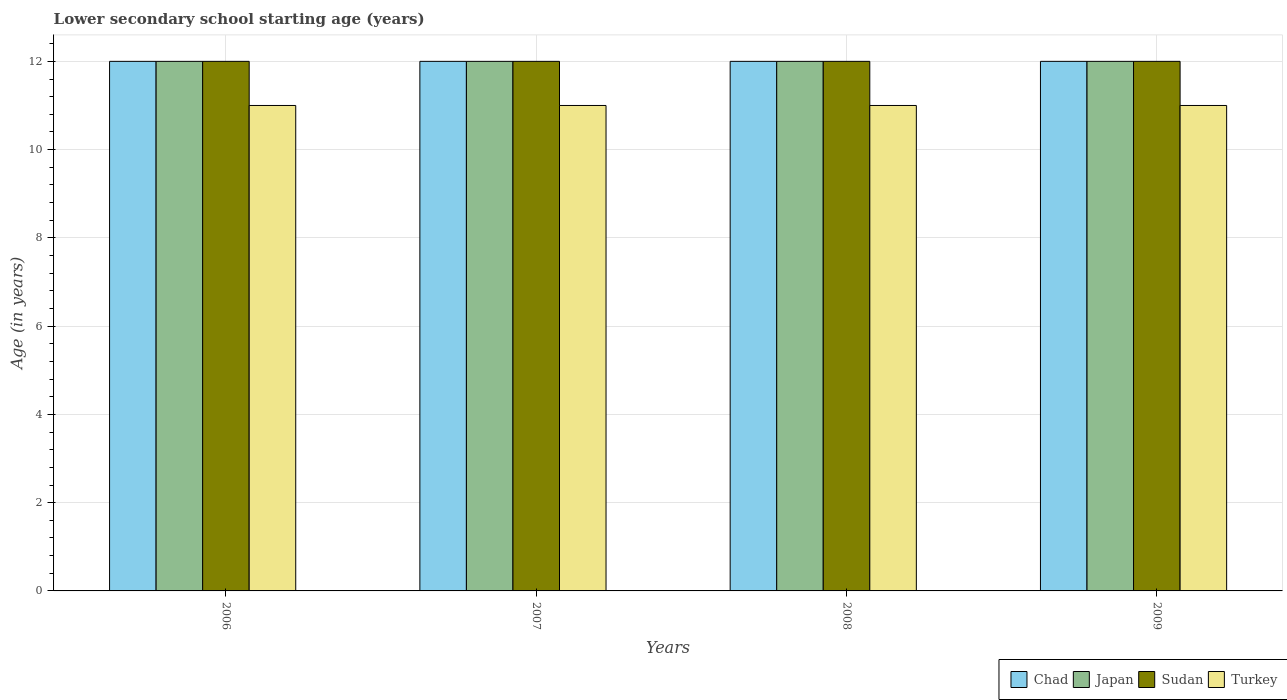What is the label of the 4th group of bars from the left?
Keep it short and to the point. 2009. What is the lower secondary school starting age of children in Turkey in 2008?
Offer a very short reply. 11. Across all years, what is the maximum lower secondary school starting age of children in Sudan?
Your answer should be very brief. 12. Across all years, what is the minimum lower secondary school starting age of children in Turkey?
Your response must be concise. 11. In which year was the lower secondary school starting age of children in Sudan maximum?
Ensure brevity in your answer.  2006. In which year was the lower secondary school starting age of children in Japan minimum?
Make the answer very short. 2006. What is the total lower secondary school starting age of children in Chad in the graph?
Provide a short and direct response. 48. What is the difference between the lower secondary school starting age of children in Chad in 2006 and that in 2007?
Your answer should be very brief. 0. What is the difference between the lower secondary school starting age of children in Japan in 2007 and the lower secondary school starting age of children in Chad in 2009?
Offer a very short reply. 0. What is the average lower secondary school starting age of children in Japan per year?
Your answer should be very brief. 12. In the year 2006, what is the difference between the lower secondary school starting age of children in Chad and lower secondary school starting age of children in Turkey?
Offer a very short reply. 1. What is the difference between the highest and the second highest lower secondary school starting age of children in Chad?
Offer a terse response. 0. Is the sum of the lower secondary school starting age of children in Sudan in 2007 and 2008 greater than the maximum lower secondary school starting age of children in Turkey across all years?
Give a very brief answer. Yes. What does the 3rd bar from the left in 2006 represents?
Your answer should be compact. Sudan. How many bars are there?
Offer a very short reply. 16. How many years are there in the graph?
Provide a short and direct response. 4. Are the values on the major ticks of Y-axis written in scientific E-notation?
Keep it short and to the point. No. Does the graph contain grids?
Keep it short and to the point. Yes. How many legend labels are there?
Offer a terse response. 4. What is the title of the graph?
Ensure brevity in your answer.  Lower secondary school starting age (years). Does "New Caledonia" appear as one of the legend labels in the graph?
Provide a succinct answer. No. What is the label or title of the Y-axis?
Provide a short and direct response. Age (in years). What is the Age (in years) in Japan in 2006?
Offer a terse response. 12. What is the Age (in years) in Sudan in 2006?
Provide a short and direct response. 12. What is the Age (in years) in Turkey in 2006?
Offer a very short reply. 11. What is the Age (in years) in Sudan in 2007?
Provide a short and direct response. 12. What is the Age (in years) in Turkey in 2007?
Offer a terse response. 11. What is the Age (in years) of Chad in 2008?
Offer a terse response. 12. What is the Age (in years) in Sudan in 2008?
Offer a very short reply. 12. What is the Age (in years) in Japan in 2009?
Offer a terse response. 12. Across all years, what is the maximum Age (in years) in Chad?
Make the answer very short. 12. Across all years, what is the maximum Age (in years) in Japan?
Offer a very short reply. 12. Across all years, what is the maximum Age (in years) of Sudan?
Provide a succinct answer. 12. Across all years, what is the maximum Age (in years) in Turkey?
Keep it short and to the point. 11. Across all years, what is the minimum Age (in years) of Sudan?
Provide a short and direct response. 12. What is the total Age (in years) in Japan in the graph?
Keep it short and to the point. 48. What is the total Age (in years) of Turkey in the graph?
Provide a short and direct response. 44. What is the difference between the Age (in years) of Chad in 2006 and that in 2007?
Your answer should be compact. 0. What is the difference between the Age (in years) of Japan in 2006 and that in 2007?
Provide a short and direct response. 0. What is the difference between the Age (in years) of Sudan in 2006 and that in 2007?
Offer a very short reply. 0. What is the difference between the Age (in years) in Turkey in 2006 and that in 2007?
Ensure brevity in your answer.  0. What is the difference between the Age (in years) in Turkey in 2006 and that in 2008?
Your answer should be compact. 0. What is the difference between the Age (in years) of Chad in 2006 and that in 2009?
Offer a very short reply. 0. What is the difference between the Age (in years) in Japan in 2006 and that in 2009?
Your response must be concise. 0. What is the difference between the Age (in years) of Sudan in 2006 and that in 2009?
Make the answer very short. 0. What is the difference between the Age (in years) of Japan in 2007 and that in 2008?
Make the answer very short. 0. What is the difference between the Age (in years) in Sudan in 2007 and that in 2008?
Make the answer very short. 0. What is the difference between the Age (in years) in Japan in 2007 and that in 2009?
Give a very brief answer. 0. What is the difference between the Age (in years) of Sudan in 2007 and that in 2009?
Give a very brief answer. 0. What is the difference between the Age (in years) of Turkey in 2007 and that in 2009?
Keep it short and to the point. 0. What is the difference between the Age (in years) in Japan in 2008 and that in 2009?
Offer a terse response. 0. What is the difference between the Age (in years) of Sudan in 2008 and that in 2009?
Your answer should be compact. 0. What is the difference between the Age (in years) in Turkey in 2008 and that in 2009?
Offer a very short reply. 0. What is the difference between the Age (in years) in Chad in 2006 and the Age (in years) in Japan in 2007?
Ensure brevity in your answer.  0. What is the difference between the Age (in years) of Chad in 2006 and the Age (in years) of Sudan in 2007?
Provide a short and direct response. 0. What is the difference between the Age (in years) in Chad in 2006 and the Age (in years) in Turkey in 2007?
Offer a very short reply. 1. What is the difference between the Age (in years) of Japan in 2006 and the Age (in years) of Sudan in 2007?
Your answer should be compact. 0. What is the difference between the Age (in years) in Sudan in 2006 and the Age (in years) in Turkey in 2007?
Provide a succinct answer. 1. What is the difference between the Age (in years) of Chad in 2006 and the Age (in years) of Sudan in 2008?
Keep it short and to the point. 0. What is the difference between the Age (in years) in Chad in 2006 and the Age (in years) in Turkey in 2008?
Give a very brief answer. 1. What is the difference between the Age (in years) in Japan in 2006 and the Age (in years) in Turkey in 2008?
Give a very brief answer. 1. What is the difference between the Age (in years) of Sudan in 2006 and the Age (in years) of Turkey in 2008?
Provide a succinct answer. 1. What is the difference between the Age (in years) in Chad in 2006 and the Age (in years) in Japan in 2009?
Offer a very short reply. 0. What is the difference between the Age (in years) of Chad in 2006 and the Age (in years) of Sudan in 2009?
Ensure brevity in your answer.  0. What is the difference between the Age (in years) in Chad in 2006 and the Age (in years) in Turkey in 2009?
Your response must be concise. 1. What is the difference between the Age (in years) of Japan in 2006 and the Age (in years) of Sudan in 2009?
Provide a succinct answer. 0. What is the difference between the Age (in years) of Japan in 2006 and the Age (in years) of Turkey in 2009?
Your response must be concise. 1. What is the difference between the Age (in years) in Sudan in 2006 and the Age (in years) in Turkey in 2009?
Offer a terse response. 1. What is the difference between the Age (in years) of Chad in 2007 and the Age (in years) of Japan in 2008?
Offer a terse response. 0. What is the difference between the Age (in years) of Chad in 2007 and the Age (in years) of Sudan in 2008?
Offer a terse response. 0. What is the difference between the Age (in years) in Chad in 2007 and the Age (in years) in Turkey in 2008?
Provide a succinct answer. 1. What is the difference between the Age (in years) of Japan in 2007 and the Age (in years) of Sudan in 2008?
Give a very brief answer. 0. What is the difference between the Age (in years) of Chad in 2007 and the Age (in years) of Sudan in 2009?
Offer a very short reply. 0. What is the difference between the Age (in years) of Chad in 2007 and the Age (in years) of Turkey in 2009?
Offer a terse response. 1. What is the difference between the Age (in years) of Chad in 2008 and the Age (in years) of Turkey in 2009?
Offer a terse response. 1. What is the difference between the Age (in years) of Japan in 2008 and the Age (in years) of Sudan in 2009?
Give a very brief answer. 0. What is the average Age (in years) in Chad per year?
Your response must be concise. 12. What is the average Age (in years) in Japan per year?
Keep it short and to the point. 12. What is the average Age (in years) in Turkey per year?
Ensure brevity in your answer.  11. In the year 2006, what is the difference between the Age (in years) in Chad and Age (in years) in Japan?
Give a very brief answer. 0. In the year 2006, what is the difference between the Age (in years) of Chad and Age (in years) of Sudan?
Your answer should be compact. 0. In the year 2006, what is the difference between the Age (in years) of Japan and Age (in years) of Turkey?
Ensure brevity in your answer.  1. In the year 2006, what is the difference between the Age (in years) of Sudan and Age (in years) of Turkey?
Offer a terse response. 1. In the year 2007, what is the difference between the Age (in years) of Chad and Age (in years) of Japan?
Keep it short and to the point. 0. In the year 2007, what is the difference between the Age (in years) in Sudan and Age (in years) in Turkey?
Your answer should be very brief. 1. In the year 2008, what is the difference between the Age (in years) in Chad and Age (in years) in Japan?
Make the answer very short. 0. In the year 2008, what is the difference between the Age (in years) in Chad and Age (in years) in Sudan?
Your answer should be compact. 0. In the year 2008, what is the difference between the Age (in years) of Japan and Age (in years) of Turkey?
Ensure brevity in your answer.  1. In the year 2008, what is the difference between the Age (in years) of Sudan and Age (in years) of Turkey?
Your answer should be very brief. 1. In the year 2009, what is the difference between the Age (in years) of Chad and Age (in years) of Japan?
Keep it short and to the point. 0. In the year 2009, what is the difference between the Age (in years) of Chad and Age (in years) of Sudan?
Make the answer very short. 0. In the year 2009, what is the difference between the Age (in years) of Japan and Age (in years) of Sudan?
Give a very brief answer. 0. In the year 2009, what is the difference between the Age (in years) in Japan and Age (in years) in Turkey?
Offer a very short reply. 1. What is the ratio of the Age (in years) in Sudan in 2006 to that in 2008?
Offer a terse response. 1. What is the ratio of the Age (in years) in Chad in 2006 to that in 2009?
Provide a short and direct response. 1. What is the ratio of the Age (in years) in Sudan in 2006 to that in 2009?
Offer a very short reply. 1. What is the ratio of the Age (in years) in Turkey in 2006 to that in 2009?
Ensure brevity in your answer.  1. What is the ratio of the Age (in years) of Chad in 2007 to that in 2008?
Your response must be concise. 1. What is the ratio of the Age (in years) of Japan in 2007 to that in 2008?
Your response must be concise. 1. What is the ratio of the Age (in years) in Sudan in 2007 to that in 2008?
Provide a short and direct response. 1. What is the ratio of the Age (in years) in Japan in 2007 to that in 2009?
Give a very brief answer. 1. What is the ratio of the Age (in years) of Sudan in 2007 to that in 2009?
Offer a very short reply. 1. What is the ratio of the Age (in years) in Turkey in 2007 to that in 2009?
Offer a terse response. 1. What is the ratio of the Age (in years) in Chad in 2008 to that in 2009?
Your answer should be compact. 1. What is the ratio of the Age (in years) of Sudan in 2008 to that in 2009?
Give a very brief answer. 1. What is the ratio of the Age (in years) of Turkey in 2008 to that in 2009?
Offer a terse response. 1. What is the difference between the highest and the second highest Age (in years) of Chad?
Offer a very short reply. 0. What is the difference between the highest and the second highest Age (in years) of Sudan?
Keep it short and to the point. 0. What is the difference between the highest and the lowest Age (in years) in Japan?
Give a very brief answer. 0. What is the difference between the highest and the lowest Age (in years) in Sudan?
Keep it short and to the point. 0. 